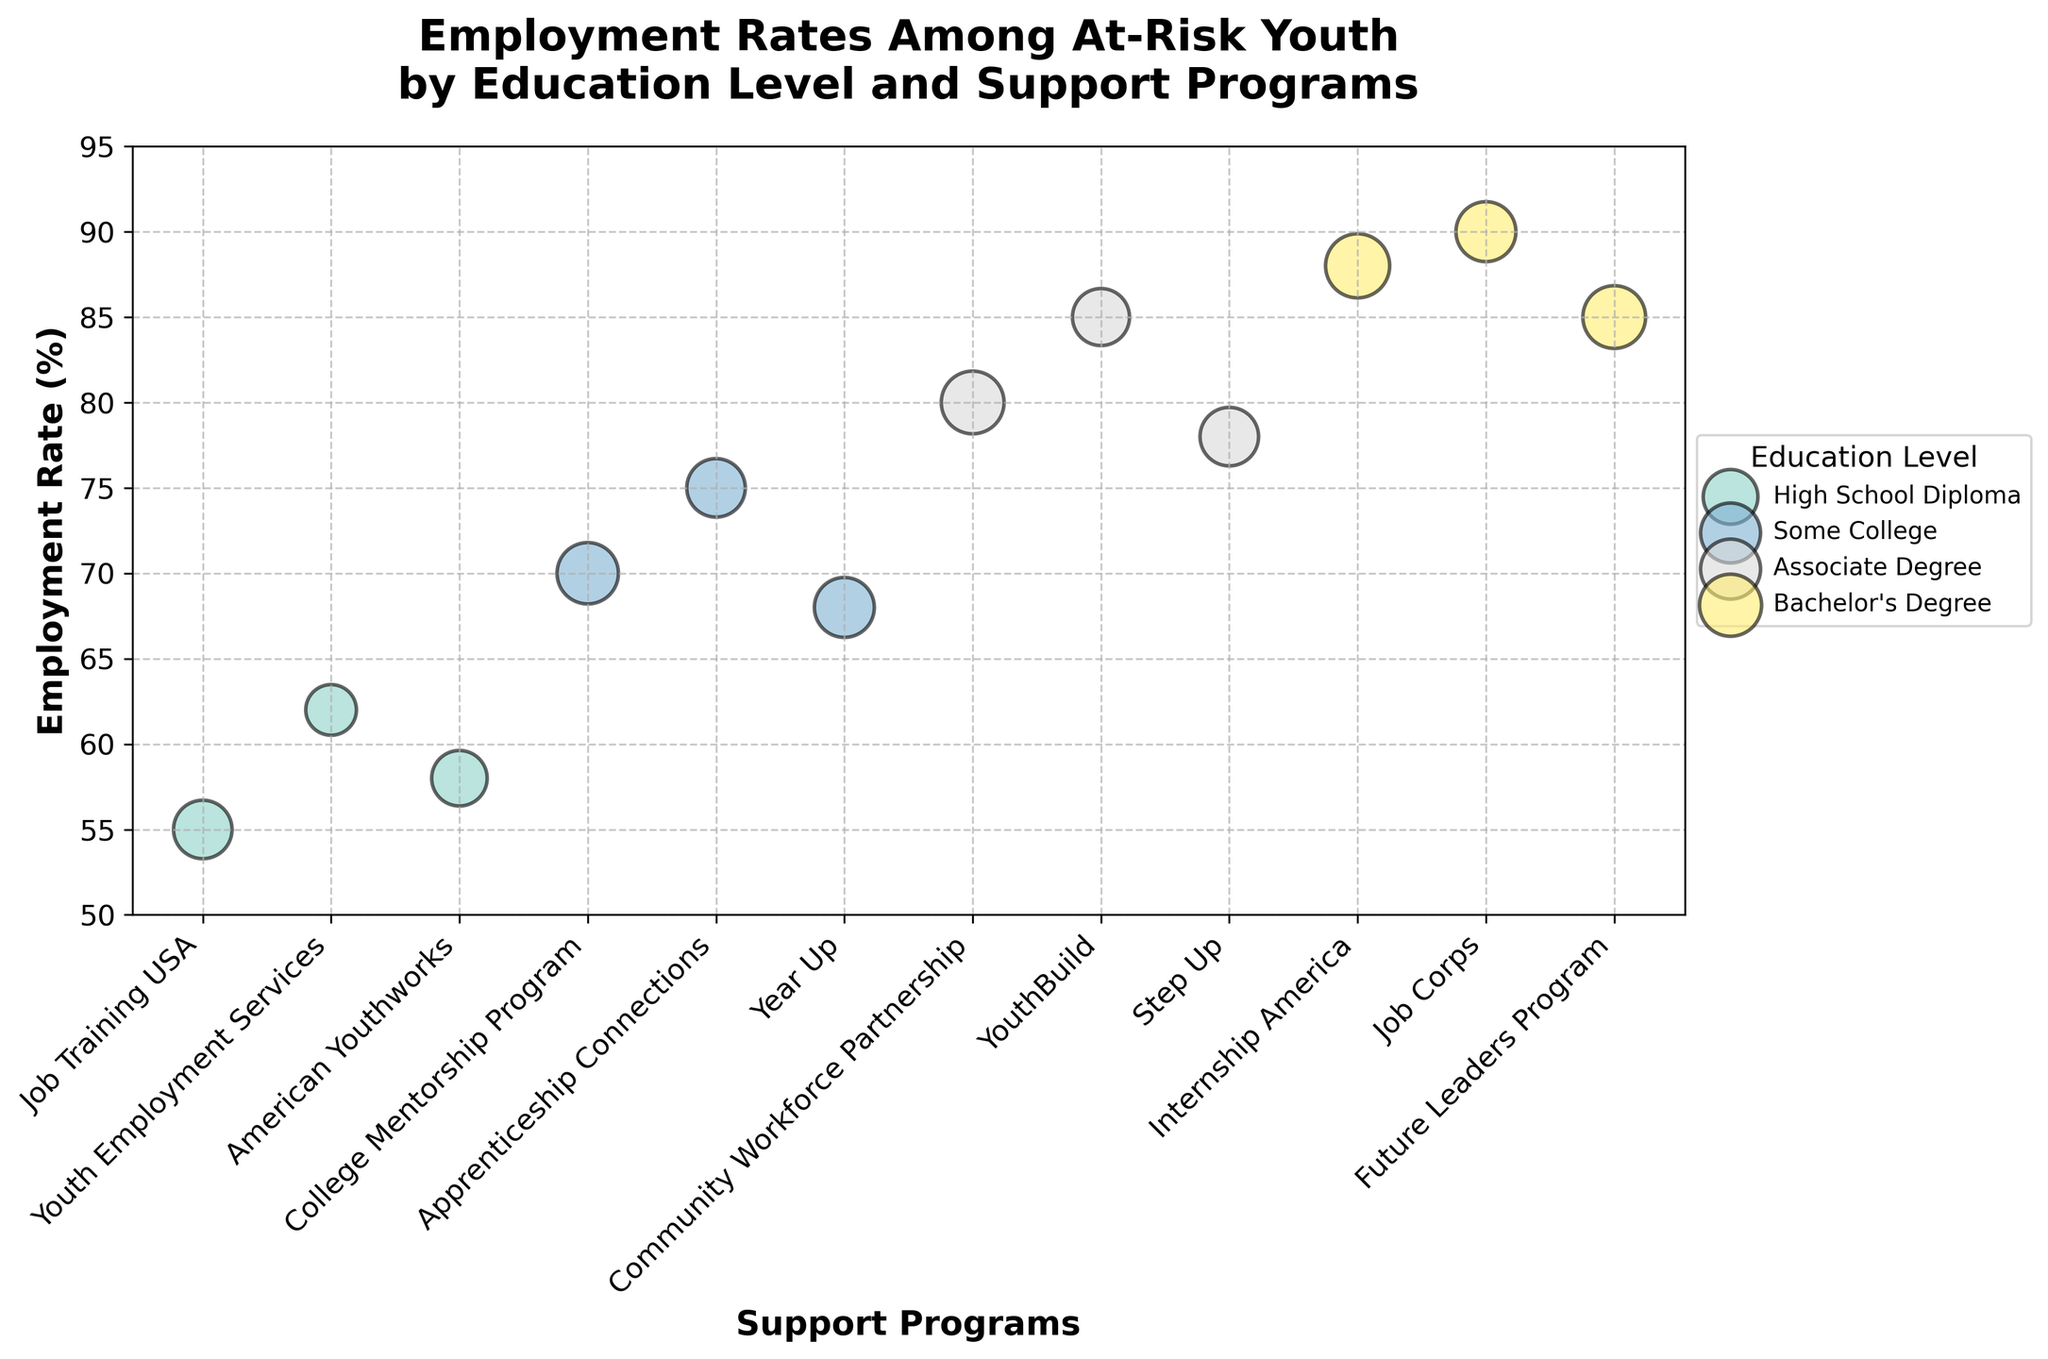what is the title of this plot? The title of a plot is usually located at the top and clearly states the main subject of the figure. Here, it reads "Employment Rates Among At-Risk Youth by Education Level and Support Programs."
Answer: Employment Rates Among At-Risk Youth by Education Level and Support Programs what is the employment rate for the "Future Leaders Program"? Locate the bubble representing the "Future Leaders Program" and check its position on the y-axis. The bubble's position indicates that the employment rate is 85%.
Answer: 85% How many education levels are represented in the figure? Look at the legend, which lists each education level represented by a different color. Count the number of different education levels listed. There are four: High School Diploma, Some College, Associate Degree, and Bachelor's Degree.
Answer: 4 Which support program has the highest employment rate? Identify the bubble positioned highest on the y-axis. This position represents the highest employment rate. The "Job Corps" has the highest rate at 90%.
Answer: Job Corps What is the average employment rate for support programs under "Associate Degree" level? Find the bubbles under "Associate Degree" and sum their employment rates: 80, 85, and 78. Then divide by the number of programs: (80 + 85 + 78) / 3 = 81
Answer: 81 How are the bubbles differentiated for each education level? The bubbles are differentiated by color for each education level. Using colors, you can identify which bubbles represent data from High School Diploma, Some College, Associate Degree, and Bachelor's Degree.
Answer: By color Which support program has the largest bubble size for "Scr, College"? Locate the bubbles representing the "Some College" education level by their color, and identify the one with the largest size. "College Mentorship Program" has the largest bubble.
Answer: College Mentorship Program Is the employment rate higher for "YouthBuild" or "Job Training USA"? Compare the positions of the bubbles representing "YouthBuild" and "Job Training USA" on the y-axis. "YouthBuild" has an employment rate of 85%, and "Job Training USA" has 55%.
Answer: YouthBuild Does "Community Workforce Partnership" have a higher employment rate than "Step Up"? Compare the y-axis positions of the bubbles for "Community Workforce Partnership" (80%) and "Step Up" (78%). "Community Workforce Partnership" is higher.
Answer: Yes What trend is observed between education level and employment rate? Observe that as the education level increases (from High School Diploma to Bachelor's Degree), the employment rates generally tend to be higher, indicating a positive correlation.
Answer: Higher education levels generally have higher employment rates 